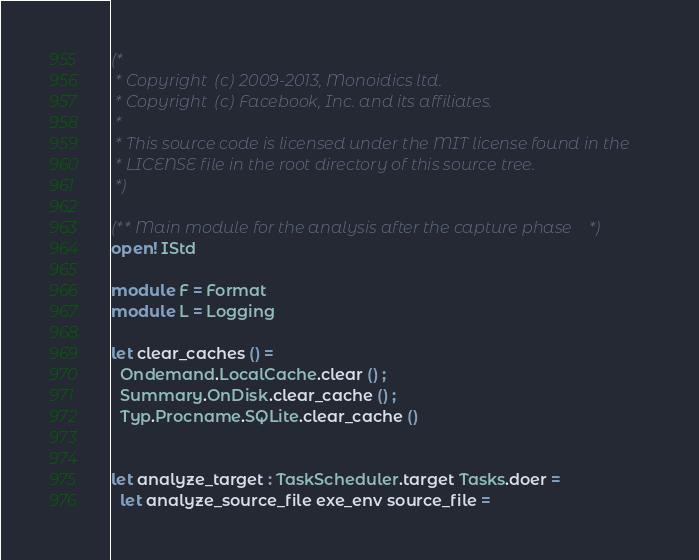Convert code to text. <code><loc_0><loc_0><loc_500><loc_500><_OCaml_>(*
 * Copyright (c) 2009-2013, Monoidics ltd.
 * Copyright (c) Facebook, Inc. and its affiliates.
 *
 * This source code is licensed under the MIT license found in the
 * LICENSE file in the root directory of this source tree.
 *)

(** Main module for the analysis after the capture phase *)
open! IStd

module F = Format
module L = Logging

let clear_caches () =
  Ondemand.LocalCache.clear () ;
  Summary.OnDisk.clear_cache () ;
  Typ.Procname.SQLite.clear_cache ()


let analyze_target : TaskScheduler.target Tasks.doer =
  let analyze_source_file exe_env source_file =</code> 